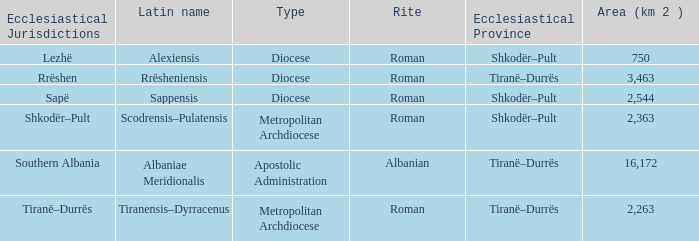Give me the full table as a dictionary. {'header': ['Ecclesiastical Jurisdictions', 'Latin name', 'Type', 'Rite', 'Ecclesiastical Province', 'Area (km 2 )'], 'rows': [['Lezhë', 'Alexiensis', 'Diocese', 'Roman', 'Shkodër–Pult', '750'], ['Rrëshen', 'Rrësheniensis', 'Diocese', 'Roman', 'Tiranë–Durrës', '3,463'], ['Sapë', 'Sappensis', 'Diocese', 'Roman', 'Shkodër–Pult', '2,544'], ['Shkodër–Pult', 'Scodrensis–Pulatensis', 'Metropolitan Archdiocese', 'Roman', 'Shkodër–Pult', '2,363'], ['Southern Albania', 'Albaniae Meridionalis', 'Apostolic Administration', 'Albanian', 'Tiranë–Durrës', '16,172'], ['Tiranë–Durrës', 'Tiranensis–Dyrracenus', 'Metropolitan Archdiocese', 'Roman', 'Tiranë–Durrës', '2,263']]} What Ecclesiastical Province has a type diocese and a latin name alexiensis? Shkodër–Pult. 